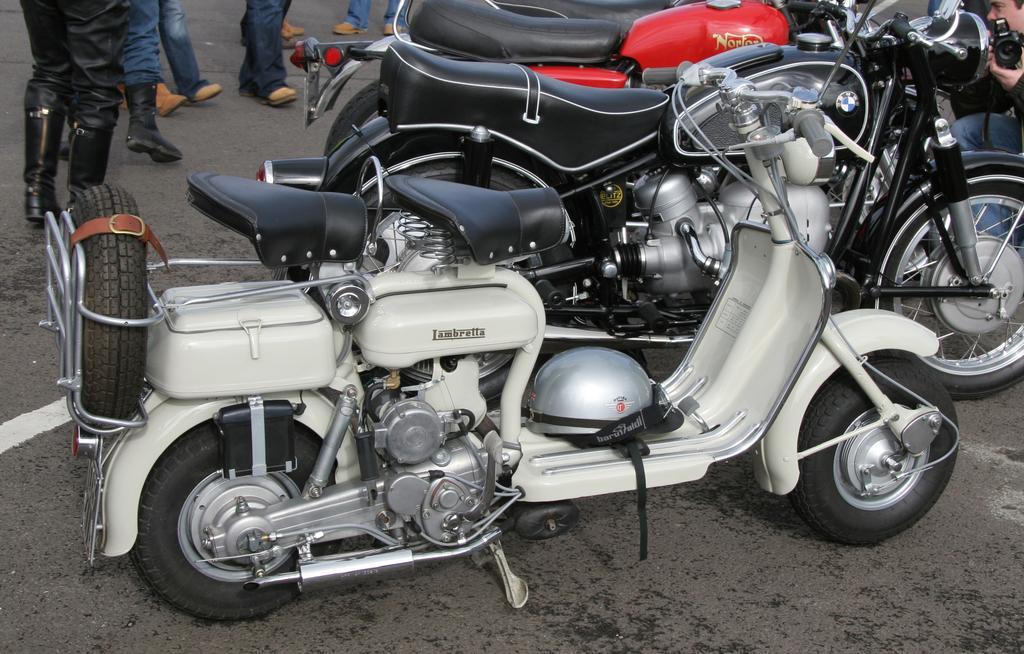Describe this image in one or two sentences. In this image there are bikes on the road. Behind the bikes there are few people standing on the road. On the right side of the image there is a person holding the camera. 